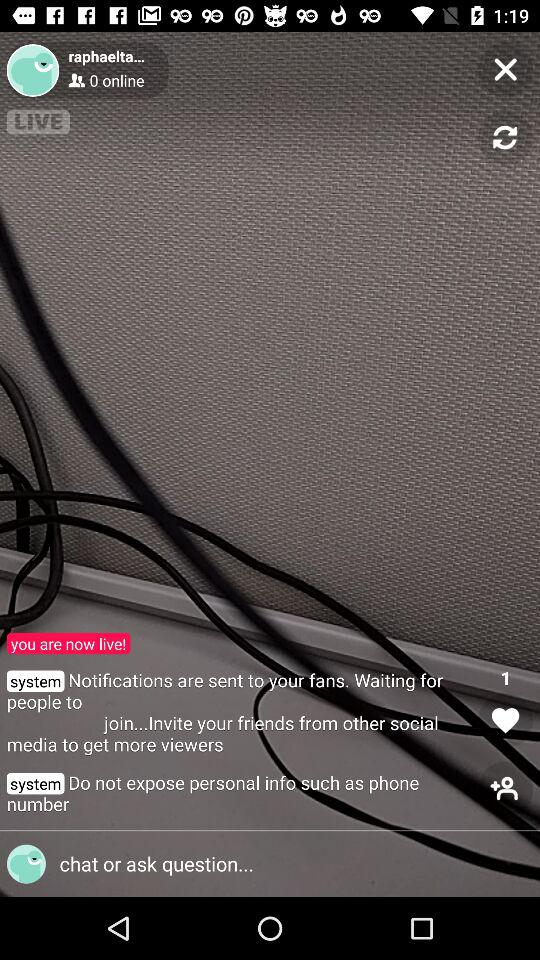How many people are online?
Answer the question using a single word or phrase. 0 